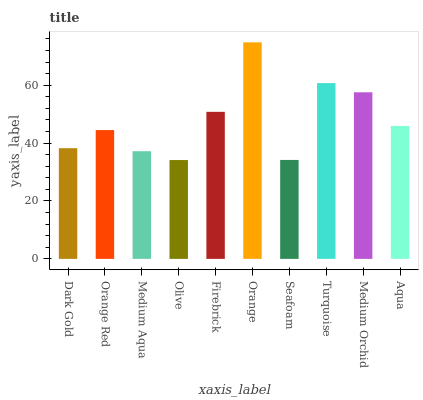Is Orange Red the minimum?
Answer yes or no. No. Is Orange Red the maximum?
Answer yes or no. No. Is Orange Red greater than Dark Gold?
Answer yes or no. Yes. Is Dark Gold less than Orange Red?
Answer yes or no. Yes. Is Dark Gold greater than Orange Red?
Answer yes or no. No. Is Orange Red less than Dark Gold?
Answer yes or no. No. Is Aqua the high median?
Answer yes or no. Yes. Is Orange Red the low median?
Answer yes or no. Yes. Is Turquoise the high median?
Answer yes or no. No. Is Orange the low median?
Answer yes or no. No. 